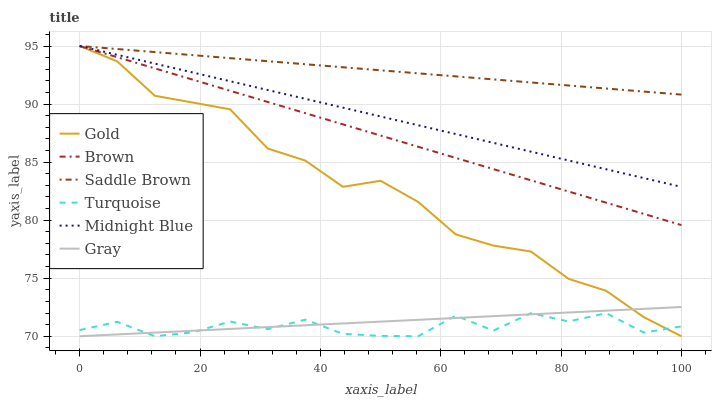Does Turquoise have the minimum area under the curve?
Answer yes or no. Yes. Does Saddle Brown have the maximum area under the curve?
Answer yes or no. Yes. Does Midnight Blue have the minimum area under the curve?
Answer yes or no. No. Does Midnight Blue have the maximum area under the curve?
Answer yes or no. No. Is Brown the smoothest?
Answer yes or no. Yes. Is Turquoise the roughest?
Answer yes or no. Yes. Is Midnight Blue the smoothest?
Answer yes or no. No. Is Midnight Blue the roughest?
Answer yes or no. No. Does Midnight Blue have the lowest value?
Answer yes or no. No. Does Saddle Brown have the highest value?
Answer yes or no. Yes. Does Turquoise have the highest value?
Answer yes or no. No. Is Gray less than Saddle Brown?
Answer yes or no. Yes. Is Brown greater than Turquoise?
Answer yes or no. Yes. Does Midnight Blue intersect Brown?
Answer yes or no. Yes. Is Midnight Blue less than Brown?
Answer yes or no. No. Is Midnight Blue greater than Brown?
Answer yes or no. No. Does Gray intersect Saddle Brown?
Answer yes or no. No. 